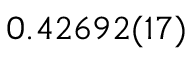Convert formula to latex. <formula><loc_0><loc_0><loc_500><loc_500>0 . 4 2 6 9 2 ( 1 7 )</formula> 